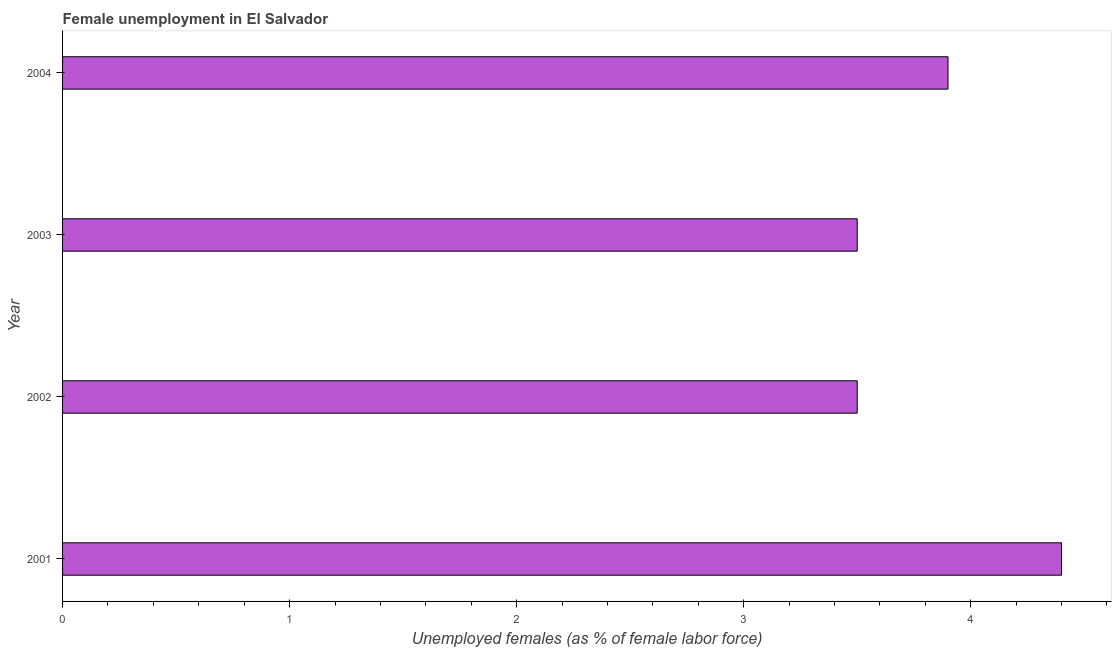What is the title of the graph?
Give a very brief answer. Female unemployment in El Salvador. What is the label or title of the X-axis?
Ensure brevity in your answer.  Unemployed females (as % of female labor force). What is the label or title of the Y-axis?
Keep it short and to the point. Year. What is the unemployed females population in 2004?
Your answer should be very brief. 3.9. Across all years, what is the maximum unemployed females population?
Keep it short and to the point. 4.4. Across all years, what is the minimum unemployed females population?
Ensure brevity in your answer.  3.5. In which year was the unemployed females population maximum?
Your response must be concise. 2001. In which year was the unemployed females population minimum?
Ensure brevity in your answer.  2002. What is the sum of the unemployed females population?
Keep it short and to the point. 15.3. What is the difference between the unemployed females population in 2001 and 2003?
Keep it short and to the point. 0.9. What is the average unemployed females population per year?
Provide a succinct answer. 3.83. What is the median unemployed females population?
Ensure brevity in your answer.  3.7. What is the ratio of the unemployed females population in 2001 to that in 2004?
Provide a succinct answer. 1.13. What is the difference between the highest and the second highest unemployed females population?
Offer a terse response. 0.5. How many bars are there?
Provide a succinct answer. 4. Are all the bars in the graph horizontal?
Provide a short and direct response. Yes. What is the difference between two consecutive major ticks on the X-axis?
Offer a terse response. 1. What is the Unemployed females (as % of female labor force) of 2001?
Your answer should be very brief. 4.4. What is the Unemployed females (as % of female labor force) in 2002?
Offer a very short reply. 3.5. What is the Unemployed females (as % of female labor force) in 2003?
Offer a terse response. 3.5. What is the Unemployed females (as % of female labor force) of 2004?
Make the answer very short. 3.9. What is the difference between the Unemployed females (as % of female labor force) in 2001 and 2004?
Ensure brevity in your answer.  0.5. What is the difference between the Unemployed females (as % of female labor force) in 2002 and 2004?
Offer a very short reply. -0.4. What is the ratio of the Unemployed females (as % of female labor force) in 2001 to that in 2002?
Offer a very short reply. 1.26. What is the ratio of the Unemployed females (as % of female labor force) in 2001 to that in 2003?
Give a very brief answer. 1.26. What is the ratio of the Unemployed females (as % of female labor force) in 2001 to that in 2004?
Make the answer very short. 1.13. What is the ratio of the Unemployed females (as % of female labor force) in 2002 to that in 2003?
Your response must be concise. 1. What is the ratio of the Unemployed females (as % of female labor force) in 2002 to that in 2004?
Provide a short and direct response. 0.9. What is the ratio of the Unemployed females (as % of female labor force) in 2003 to that in 2004?
Your answer should be compact. 0.9. 